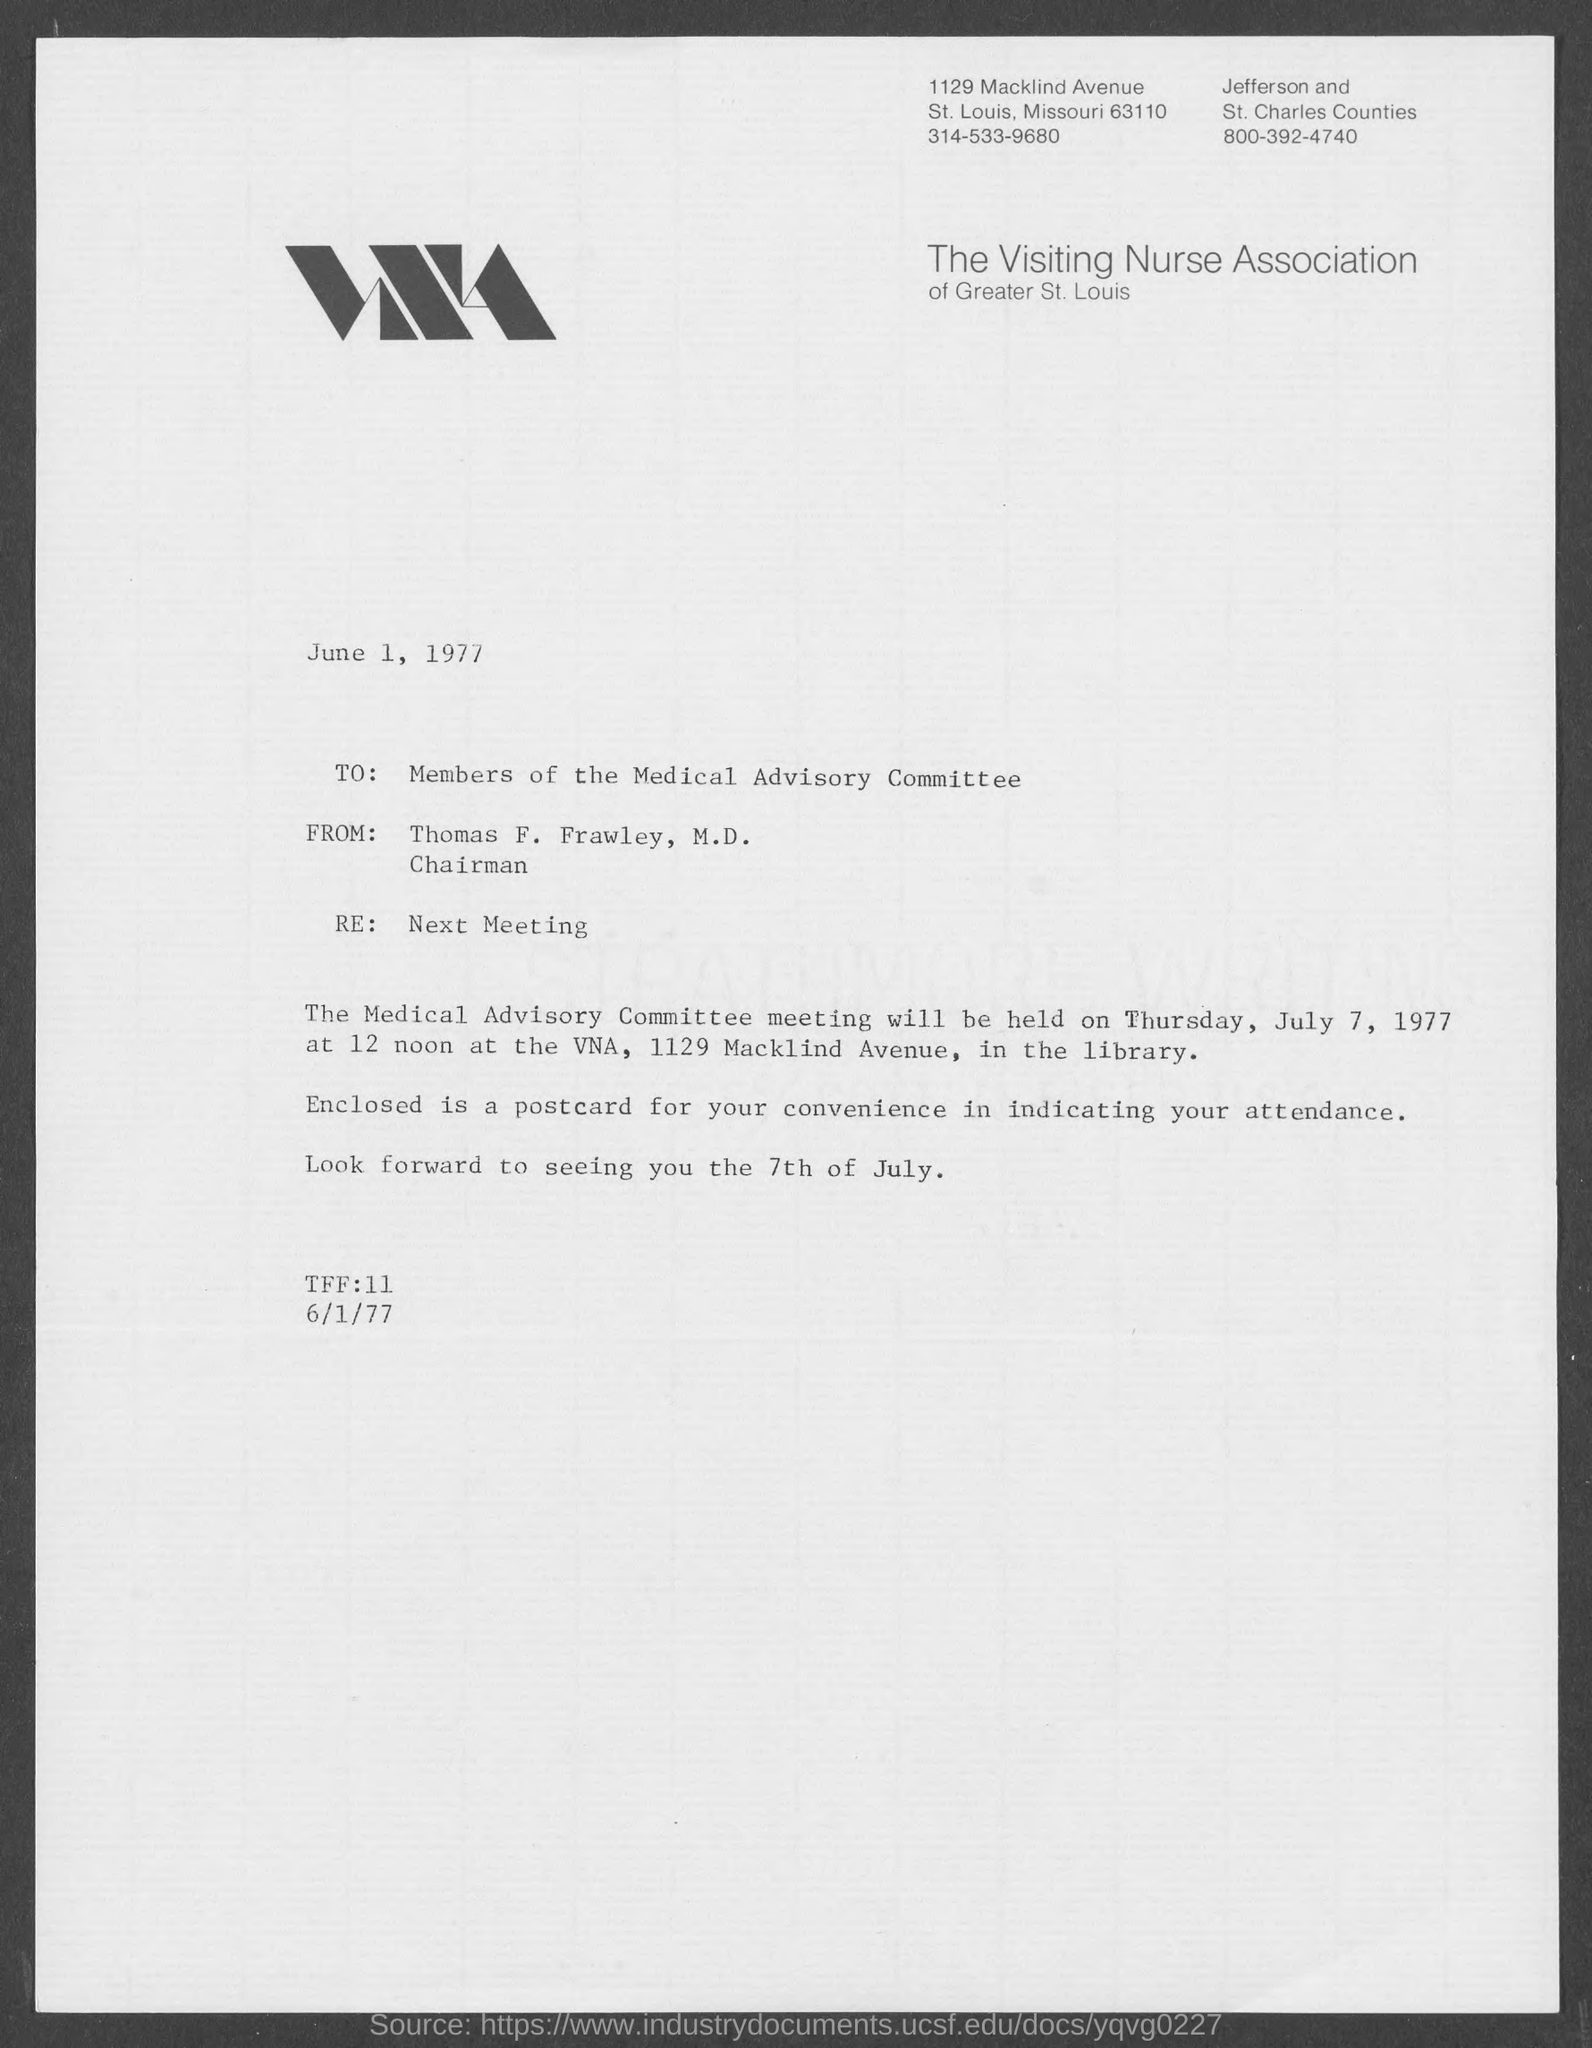When is the memorandum dated?
Your response must be concise. June 1, 1977. What is the re. of memorandum ?
Keep it short and to the point. Next Meeting. What is the position of thomas f. frawley, m.d.,?
Give a very brief answer. Chairman. 